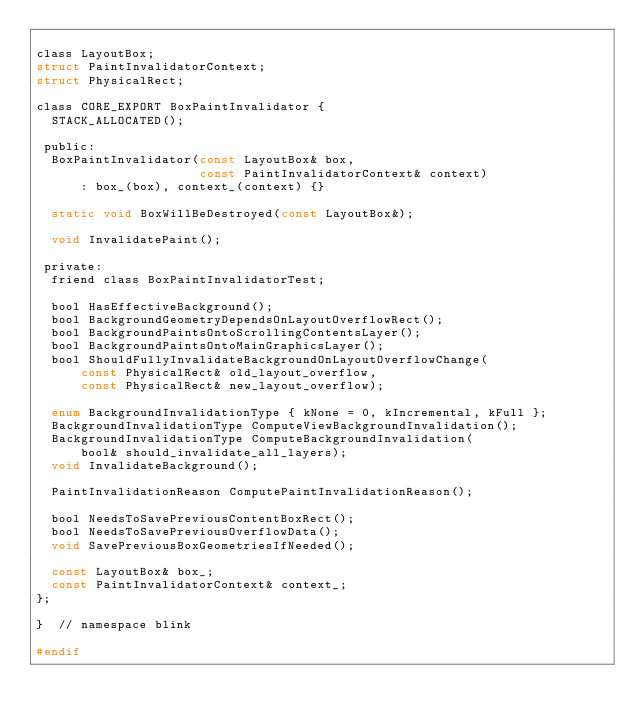Convert code to text. <code><loc_0><loc_0><loc_500><loc_500><_C_>
class LayoutBox;
struct PaintInvalidatorContext;
struct PhysicalRect;

class CORE_EXPORT BoxPaintInvalidator {
  STACK_ALLOCATED();

 public:
  BoxPaintInvalidator(const LayoutBox& box,
                      const PaintInvalidatorContext& context)
      : box_(box), context_(context) {}

  static void BoxWillBeDestroyed(const LayoutBox&);

  void InvalidatePaint();

 private:
  friend class BoxPaintInvalidatorTest;

  bool HasEffectiveBackground();
  bool BackgroundGeometryDependsOnLayoutOverflowRect();
  bool BackgroundPaintsOntoScrollingContentsLayer();
  bool BackgroundPaintsOntoMainGraphicsLayer();
  bool ShouldFullyInvalidateBackgroundOnLayoutOverflowChange(
      const PhysicalRect& old_layout_overflow,
      const PhysicalRect& new_layout_overflow);

  enum BackgroundInvalidationType { kNone = 0, kIncremental, kFull };
  BackgroundInvalidationType ComputeViewBackgroundInvalidation();
  BackgroundInvalidationType ComputeBackgroundInvalidation(
      bool& should_invalidate_all_layers);
  void InvalidateBackground();

  PaintInvalidationReason ComputePaintInvalidationReason();

  bool NeedsToSavePreviousContentBoxRect();
  bool NeedsToSavePreviousOverflowData();
  void SavePreviousBoxGeometriesIfNeeded();

  const LayoutBox& box_;
  const PaintInvalidatorContext& context_;
};

}  // namespace blink

#endif
</code> 